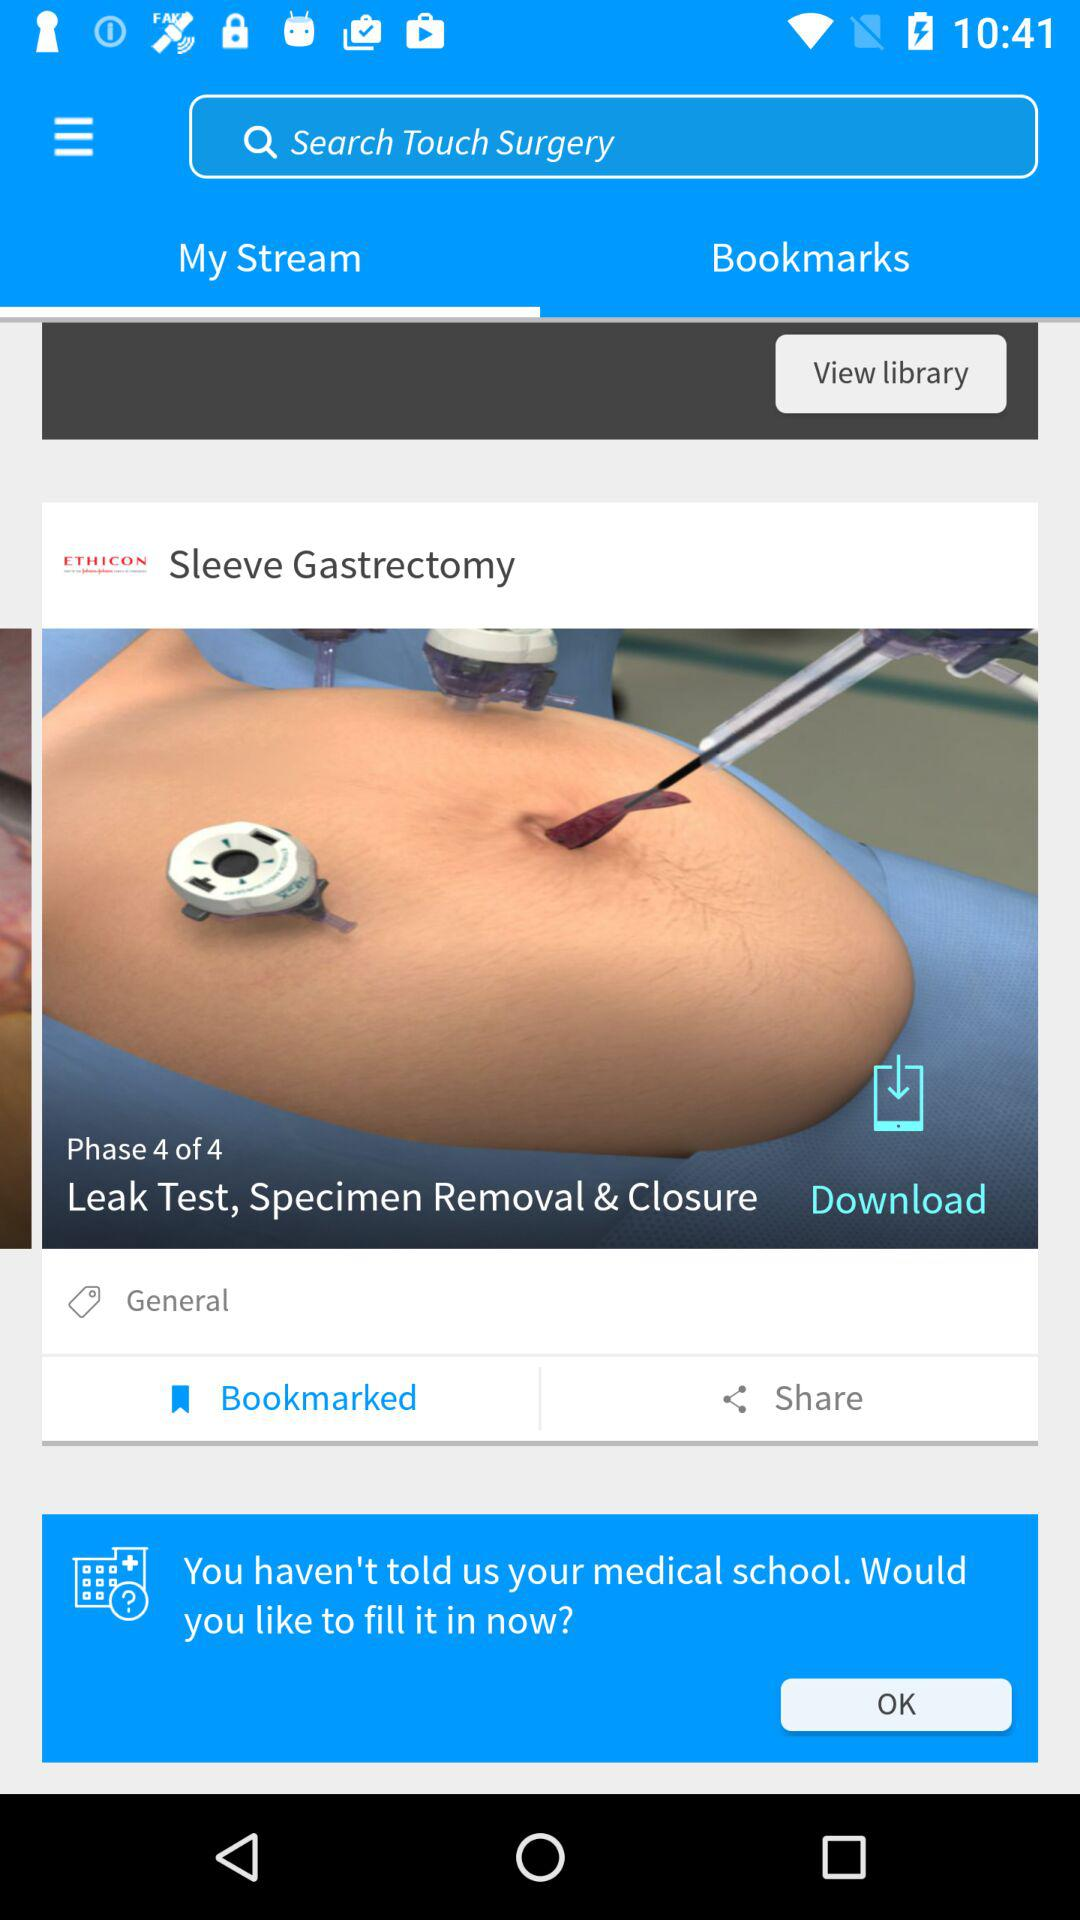Which tab is selected? The selected tab is "My Stream". 